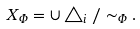<formula> <loc_0><loc_0><loc_500><loc_500>X _ { \Phi } = \cup \triangle _ { i } / \sim _ { \Phi } .</formula> 